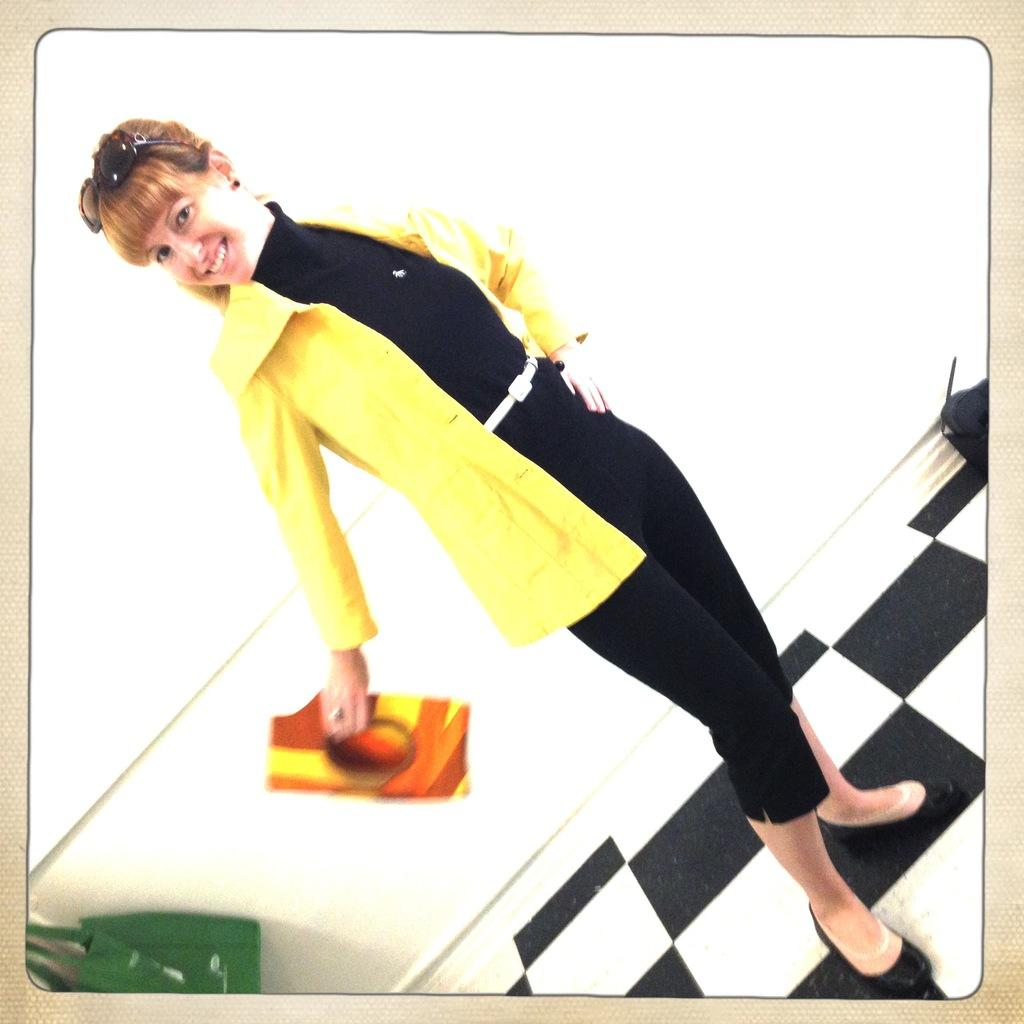Who is present in the image? There is a woman in the image. What is the woman wearing? The woman is wearing a yellow jacket. What is the woman standing on? The woman is standing on the floor. What is behind the woman? There is a wall behind the woman. What type of fork can be seen in the woman's hand in the image? There is no fork present in the image; the woman is not holding anything. 